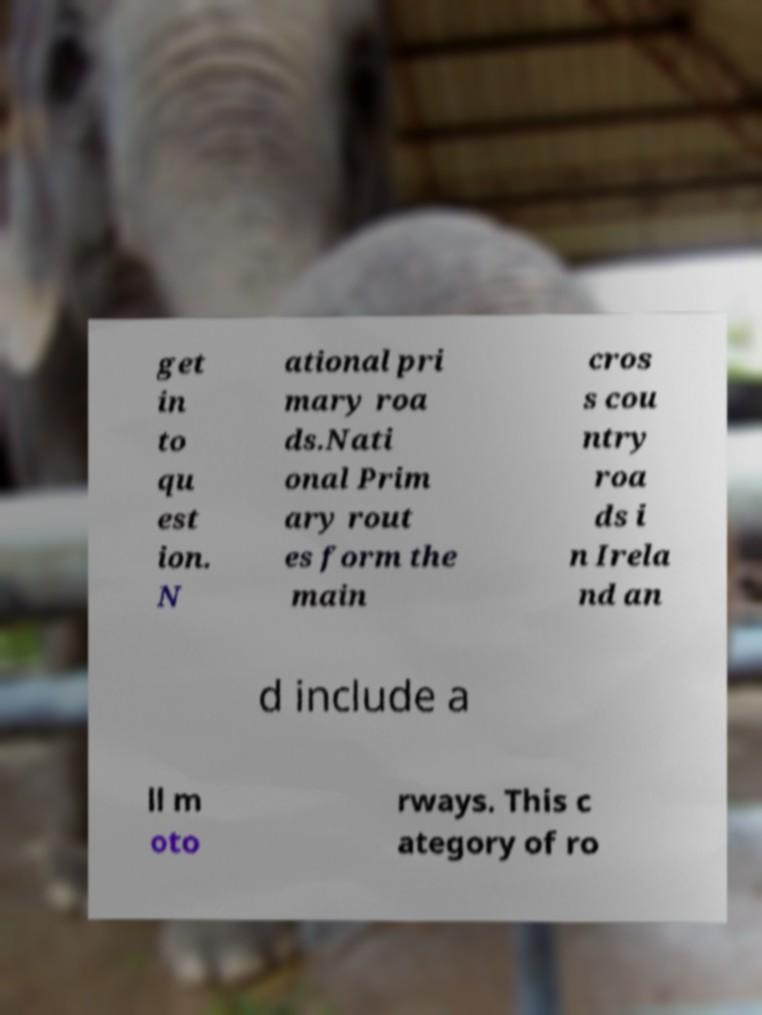Could you assist in decoding the text presented in this image and type it out clearly? get in to qu est ion. N ational pri mary roa ds.Nati onal Prim ary rout es form the main cros s cou ntry roa ds i n Irela nd an d include a ll m oto rways. This c ategory of ro 